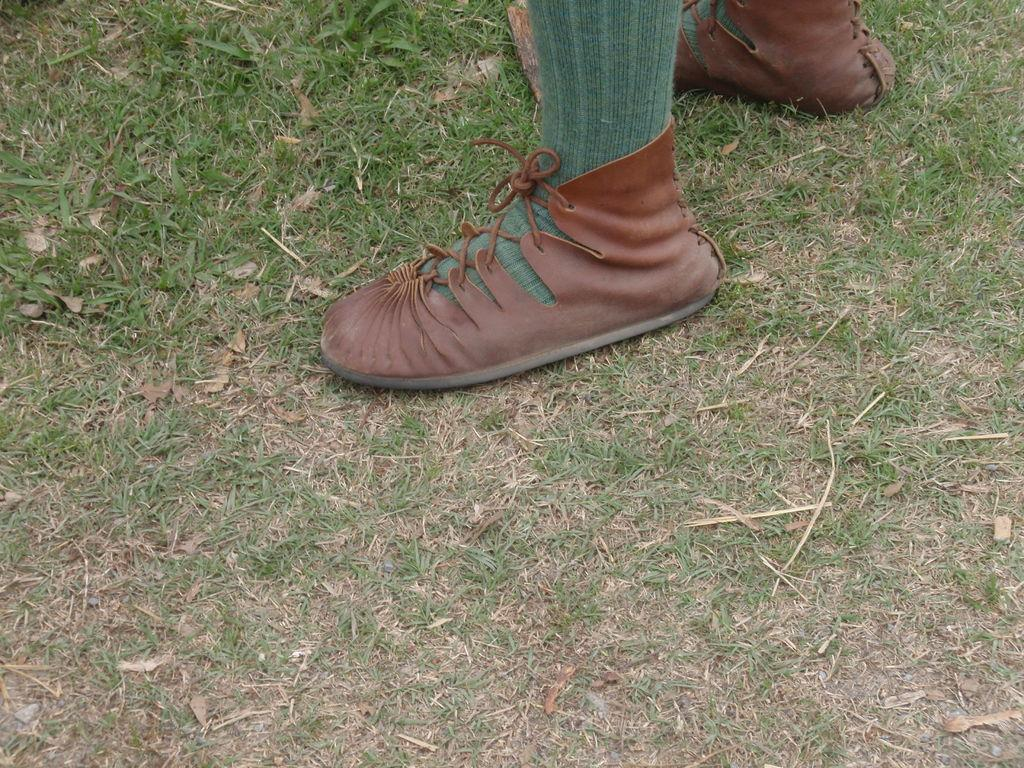Who or what is present in the image? There is a person in the image. What type of footwear is the person wearing? The person is wearing shoes. What type of surface is visible in the image? There is ground visible in the image. Is the person in the image sleeping on a bed of snow? There is no indication of snow or a bed in the image; it only shows a person wearing shoes on the ground. 